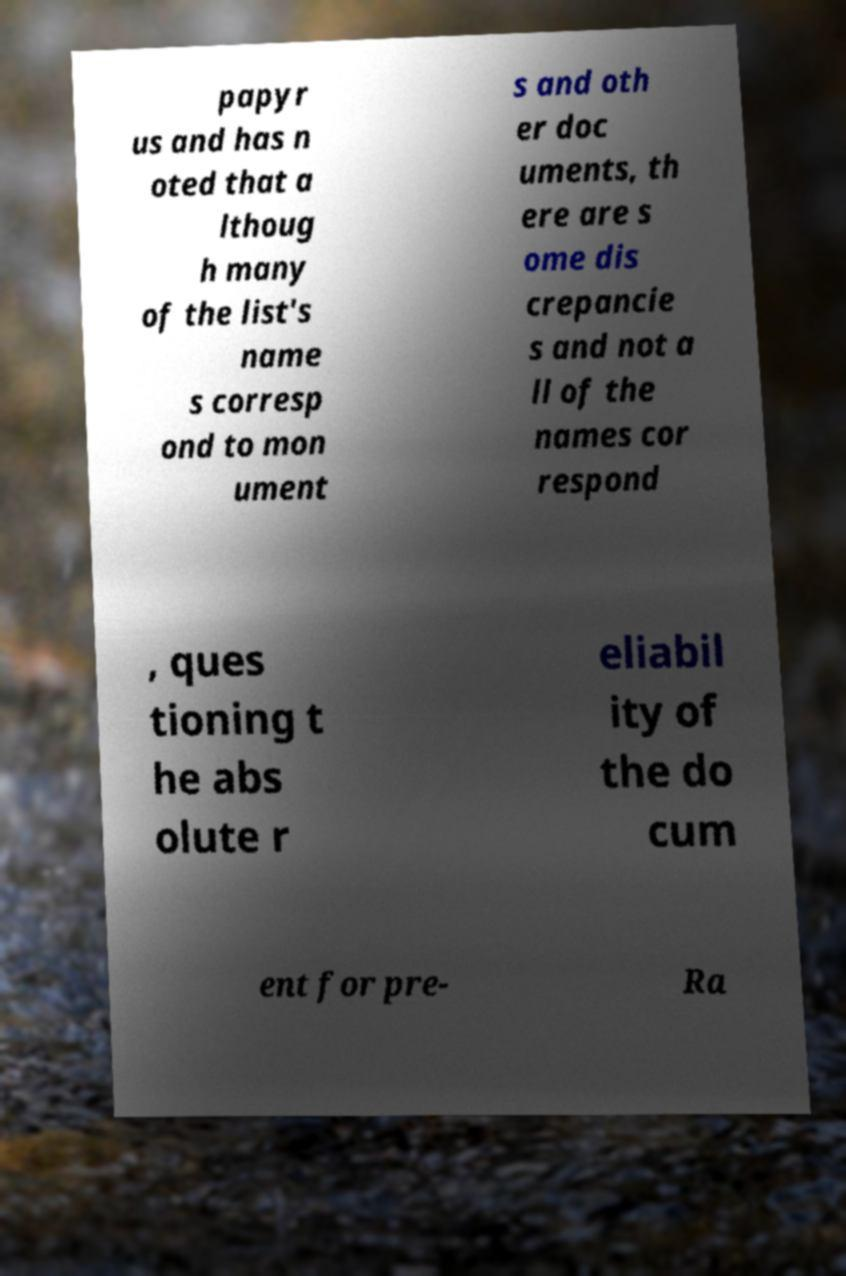Could you assist in decoding the text presented in this image and type it out clearly? papyr us and has n oted that a lthoug h many of the list's name s corresp ond to mon ument s and oth er doc uments, th ere are s ome dis crepancie s and not a ll of the names cor respond , ques tioning t he abs olute r eliabil ity of the do cum ent for pre- Ra 